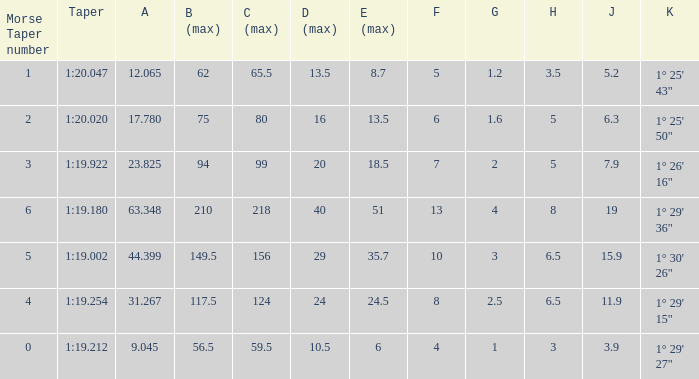Give me the full table as a dictionary. {'header': ['Morse Taper number', 'Taper', 'A', 'B (max)', 'C (max)', 'D (max)', 'E (max)', 'F', 'G', 'H', 'J', 'K'], 'rows': [['1', '1:20.047', '12.065', '62', '65.5', '13.5', '8.7', '5', '1.2', '3.5', '5.2', '1° 25\' 43"'], ['2', '1:20.020', '17.780', '75', '80', '16', '13.5', '6', '1.6', '5', '6.3', '1° 25\' 50"'], ['3', '1:19.922', '23.825', '94', '99', '20', '18.5', '7', '2', '5', '7.9', '1° 26\' 16"'], ['6', '1:19.180', '63.348', '210', '218', '40', '51', '13', '4', '8', '19', '1° 29\' 36"'], ['5', '1:19.002', '44.399', '149.5', '156', '29', '35.7', '10', '3', '6.5', '15.9', '1° 30\' 26"'], ['4', '1:19.254', '31.267', '117.5', '124', '24', '24.5', '8', '2.5', '6.5', '11.9', '1° 29\' 15"'], ['0', '1:19.212', '9.045', '56.5', '59.5', '10.5', '6', '4', '1', '3', '3.9', '1° 29\' 27"']]} Name the h when c max is 99 5.0. 